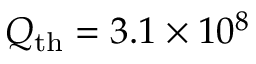Convert formula to latex. <formula><loc_0><loc_0><loc_500><loc_500>Q _ { t h } = 3 . 1 \times 1 0 ^ { 8 }</formula> 